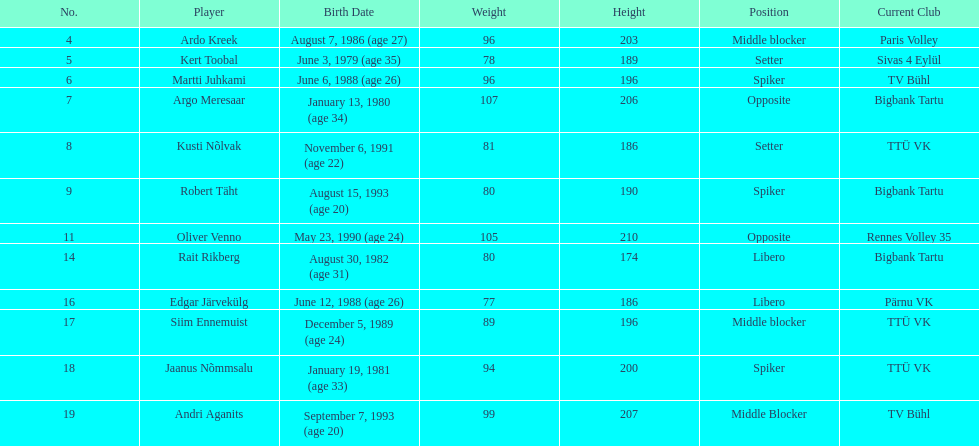After kert toobal, which player is listed as the next oldest? Argo Meresaar. 